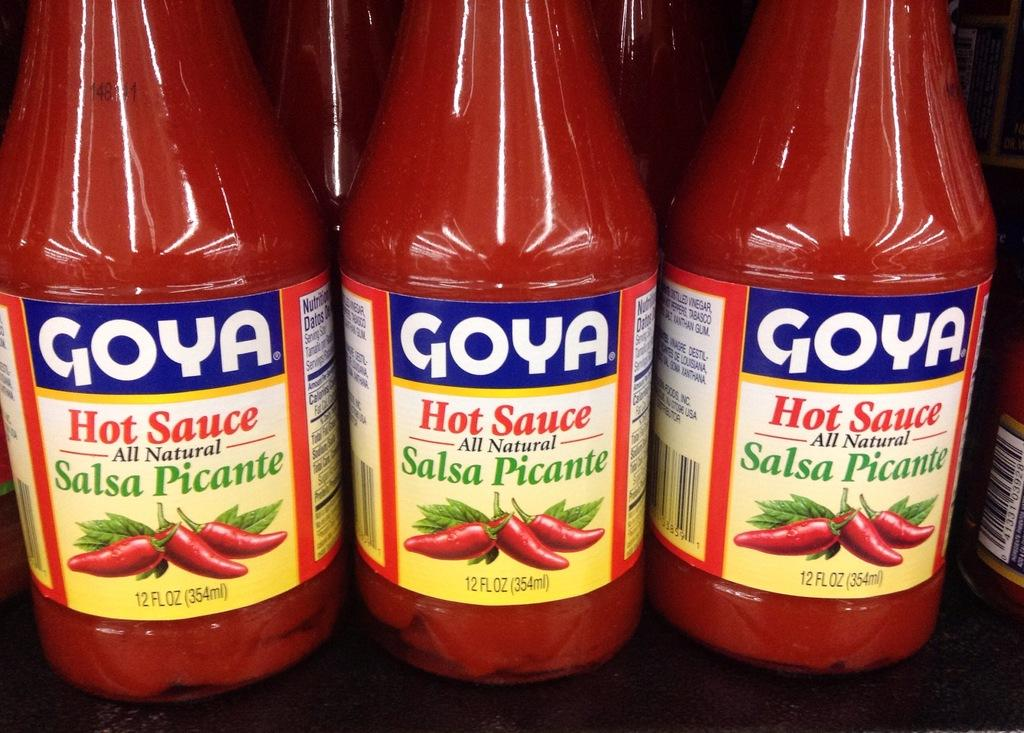What objects are present in the image? There are bottles in the image. What distinguishing feature do the bottles have? Each bottle has a label. What images are depicted on the labels? The labels have a picture of red chilies and a picture of leaves. Are there any words on the labels? Yes, the labels have some text on them. What type of operation is being performed on the books in the image? There are no books present in the image; it only features bottles with labels. 